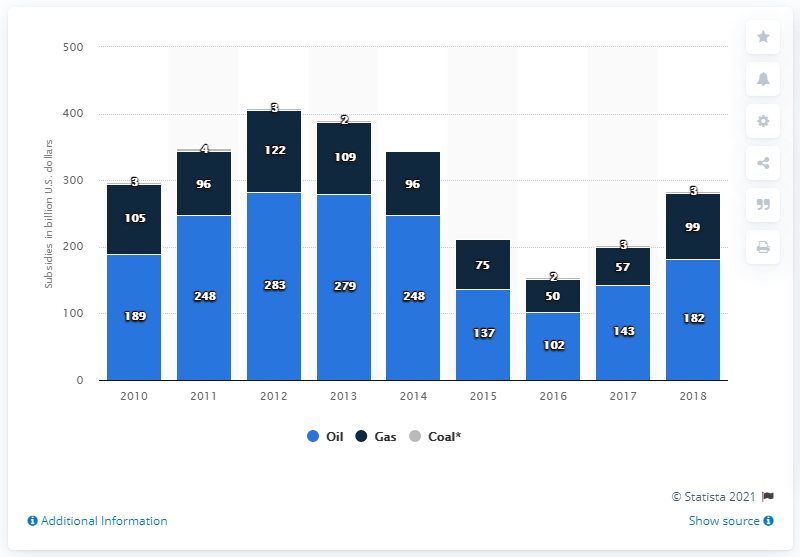Draw attention to some important aspects in this diagram. In 2018, the total amount of global subsidies for oil consumption was 182. Fossil fuel subsidies were last given out in the year 2010. 